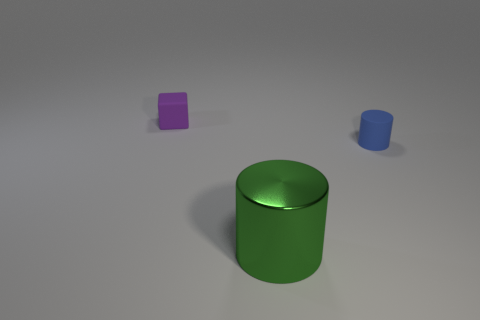Add 1 small blue rubber cylinders. How many objects exist? 4 Subtract all red blocks. Subtract all green balls. How many blocks are left? 1 Subtract all blue cubes. How many purple cylinders are left? 0 Subtract all tiny purple cubes. Subtract all green cylinders. How many objects are left? 1 Add 3 cylinders. How many cylinders are left? 5 Add 1 cylinders. How many cylinders exist? 3 Subtract 0 cyan cubes. How many objects are left? 3 Subtract all cylinders. How many objects are left? 1 Subtract 1 cubes. How many cubes are left? 0 